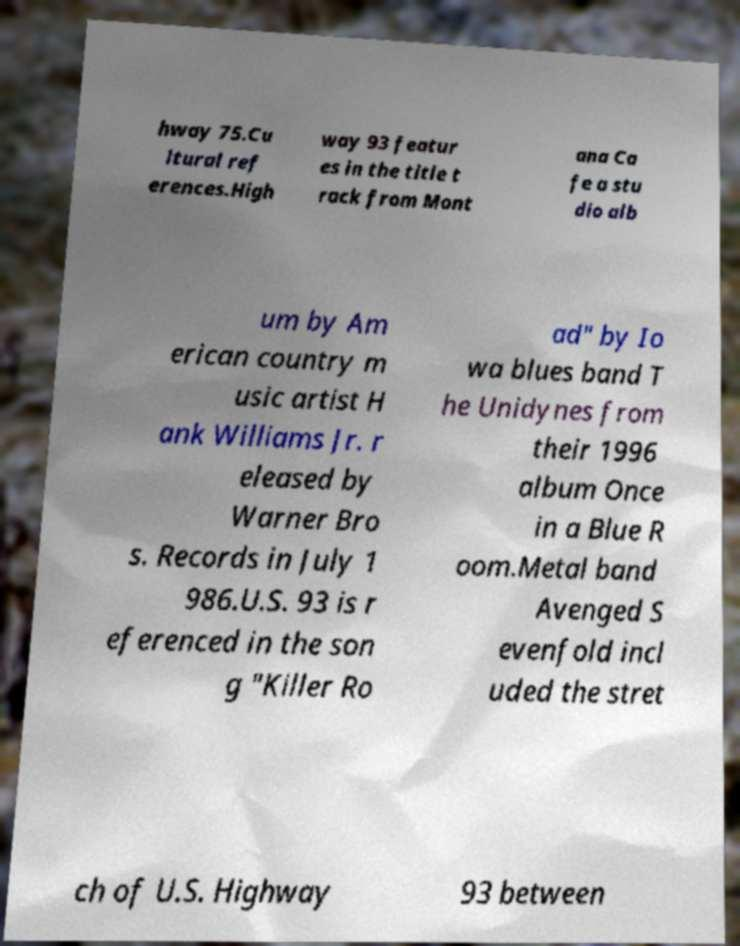Please identify and transcribe the text found in this image. hway 75.Cu ltural ref erences.High way 93 featur es in the title t rack from Mont ana Ca fe a stu dio alb um by Am erican country m usic artist H ank Williams Jr. r eleased by Warner Bro s. Records in July 1 986.U.S. 93 is r eferenced in the son g "Killer Ro ad" by Io wa blues band T he Unidynes from their 1996 album Once in a Blue R oom.Metal band Avenged S evenfold incl uded the stret ch of U.S. Highway 93 between 